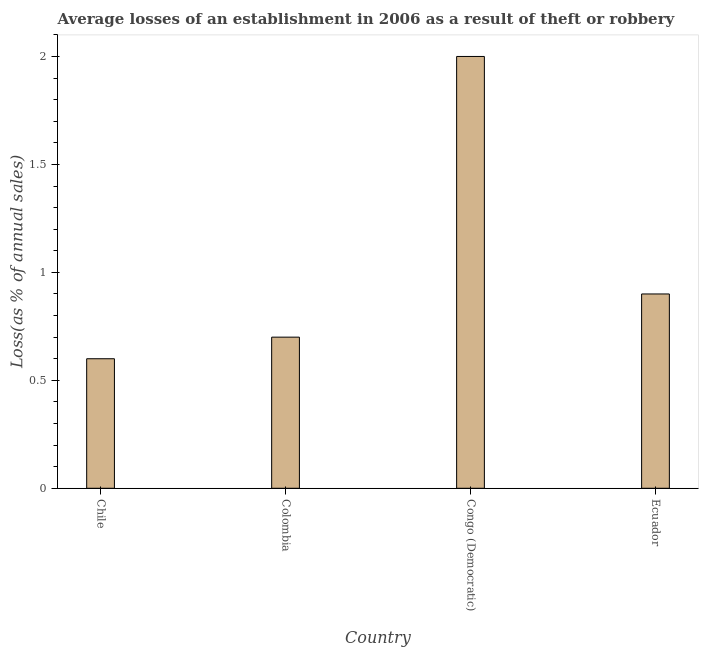What is the title of the graph?
Provide a short and direct response. Average losses of an establishment in 2006 as a result of theft or robbery. What is the label or title of the X-axis?
Offer a terse response. Country. What is the label or title of the Y-axis?
Offer a very short reply. Loss(as % of annual sales). Across all countries, what is the minimum losses due to theft?
Your response must be concise. 0.6. In which country was the losses due to theft maximum?
Give a very brief answer. Congo (Democratic). What is the average losses due to theft per country?
Offer a very short reply. 1.05. What is the ratio of the losses due to theft in Chile to that in Colombia?
Provide a short and direct response. 0.86. Is the losses due to theft in Congo (Democratic) less than that in Ecuador?
Your answer should be very brief. No. What is the difference between the highest and the second highest losses due to theft?
Provide a short and direct response. 1.1. What is the difference between the highest and the lowest losses due to theft?
Provide a succinct answer. 1.4. How many bars are there?
Your response must be concise. 4. What is the difference between two consecutive major ticks on the Y-axis?
Provide a short and direct response. 0.5. Are the values on the major ticks of Y-axis written in scientific E-notation?
Ensure brevity in your answer.  No. What is the Loss(as % of annual sales) in Chile?
Offer a terse response. 0.6. What is the Loss(as % of annual sales) of Colombia?
Offer a terse response. 0.7. What is the Loss(as % of annual sales) in Ecuador?
Offer a very short reply. 0.9. What is the difference between the Loss(as % of annual sales) in Chile and Congo (Democratic)?
Your answer should be compact. -1.4. What is the difference between the Loss(as % of annual sales) in Colombia and Congo (Democratic)?
Make the answer very short. -1.3. What is the difference between the Loss(as % of annual sales) in Colombia and Ecuador?
Your answer should be very brief. -0.2. What is the difference between the Loss(as % of annual sales) in Congo (Democratic) and Ecuador?
Offer a terse response. 1.1. What is the ratio of the Loss(as % of annual sales) in Chile to that in Colombia?
Provide a succinct answer. 0.86. What is the ratio of the Loss(as % of annual sales) in Chile to that in Congo (Democratic)?
Make the answer very short. 0.3. What is the ratio of the Loss(as % of annual sales) in Chile to that in Ecuador?
Offer a terse response. 0.67. What is the ratio of the Loss(as % of annual sales) in Colombia to that in Congo (Democratic)?
Give a very brief answer. 0.35. What is the ratio of the Loss(as % of annual sales) in Colombia to that in Ecuador?
Make the answer very short. 0.78. What is the ratio of the Loss(as % of annual sales) in Congo (Democratic) to that in Ecuador?
Make the answer very short. 2.22. 